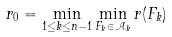<formula> <loc_0><loc_0><loc_500><loc_500>r _ { 0 } = \min _ { 1 \leq k \leq n - 1 } \min _ { F _ { k } \in \mathcal { A } _ { k } } r ( F _ { k } )</formula> 